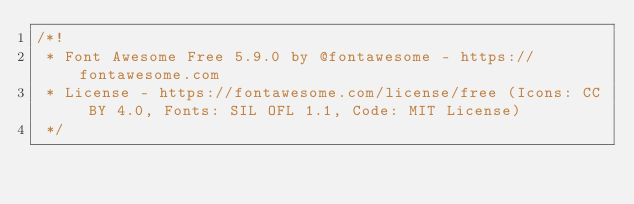<code> <loc_0><loc_0><loc_500><loc_500><_CSS_>/*!
 * Font Awesome Free 5.9.0 by @fontawesome - https://fontawesome.com
 * License - https://fontawesome.com/license/free (Icons: CC BY 4.0, Fonts: SIL OFL 1.1, Code: MIT License)
 */</code> 